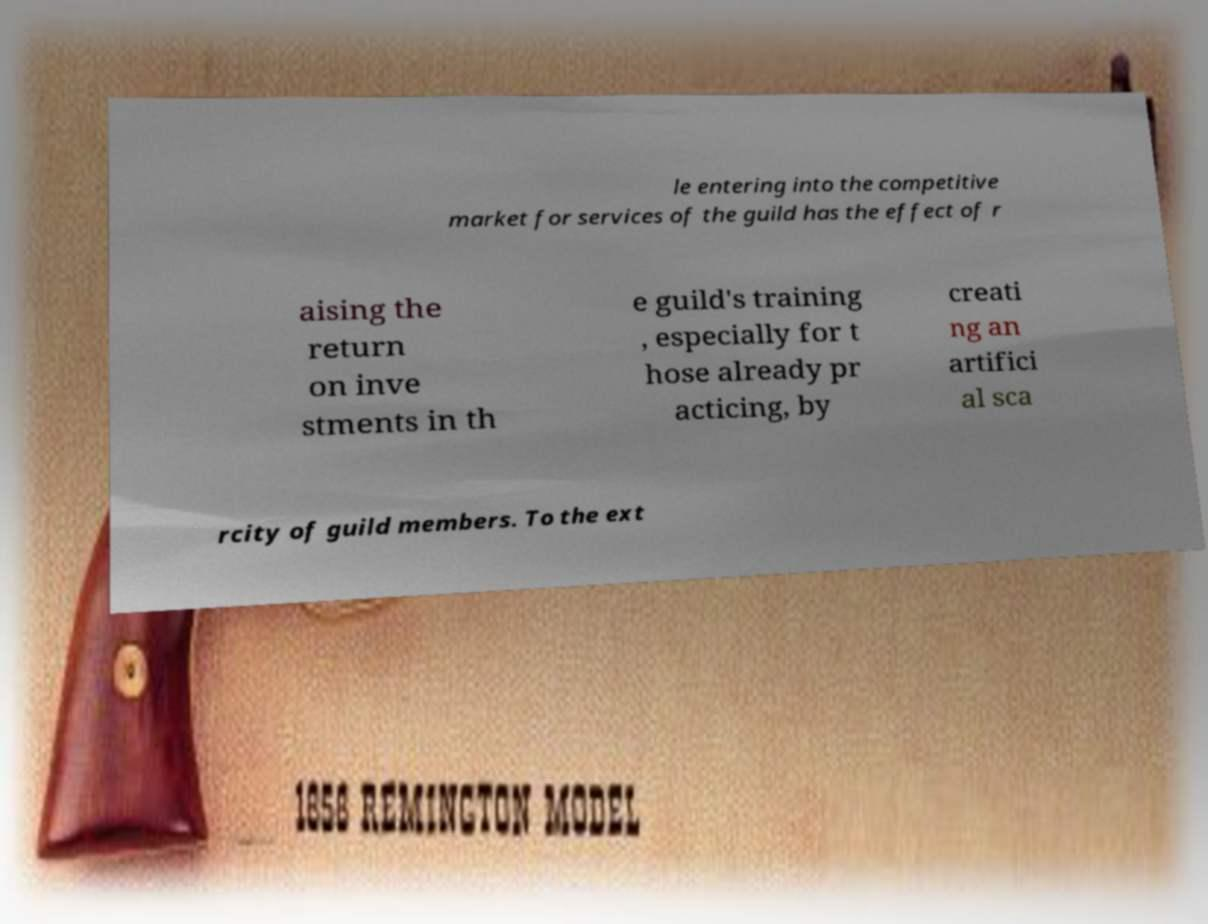There's text embedded in this image that I need extracted. Can you transcribe it verbatim? le entering into the competitive market for services of the guild has the effect of r aising the return on inve stments in th e guild's training , especially for t hose already pr acticing, by creati ng an artifici al sca rcity of guild members. To the ext 